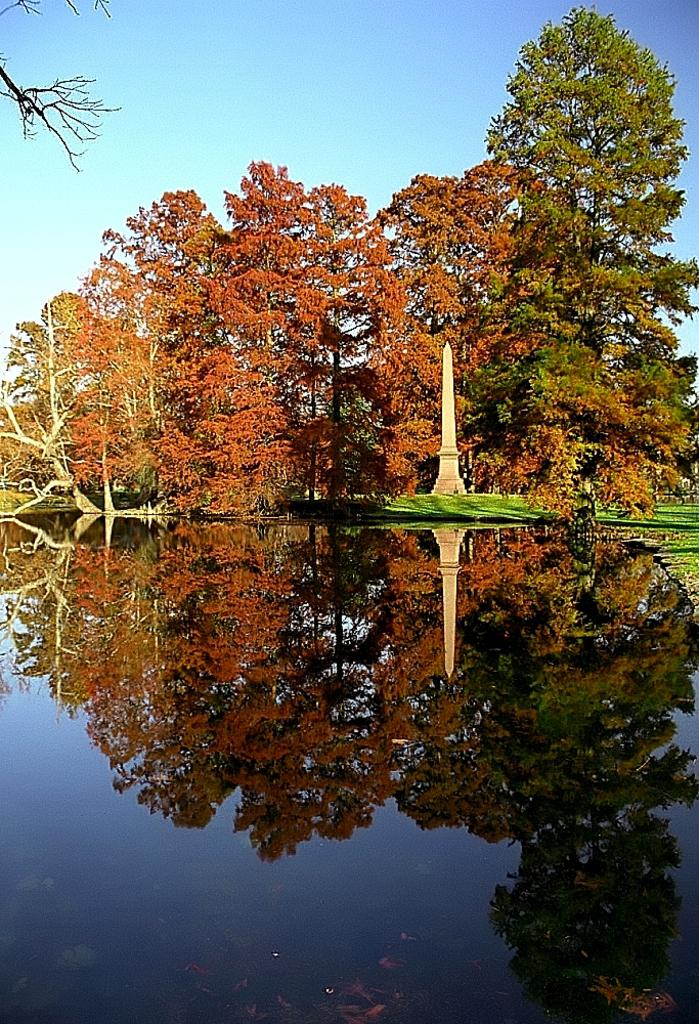What is the main element in the image? There is water in the image. What can be seen reflected in the water? There is a mirror image of trees in the water, along with a tower. What can be seen in the background of the image? There are trees and a tower in the background, as well as grass on the ground and a blue sky. How many hens are visible in the image? There are no hens present in the image. What type of trains can be seen passing by in the image? There are no trains present in the image. 